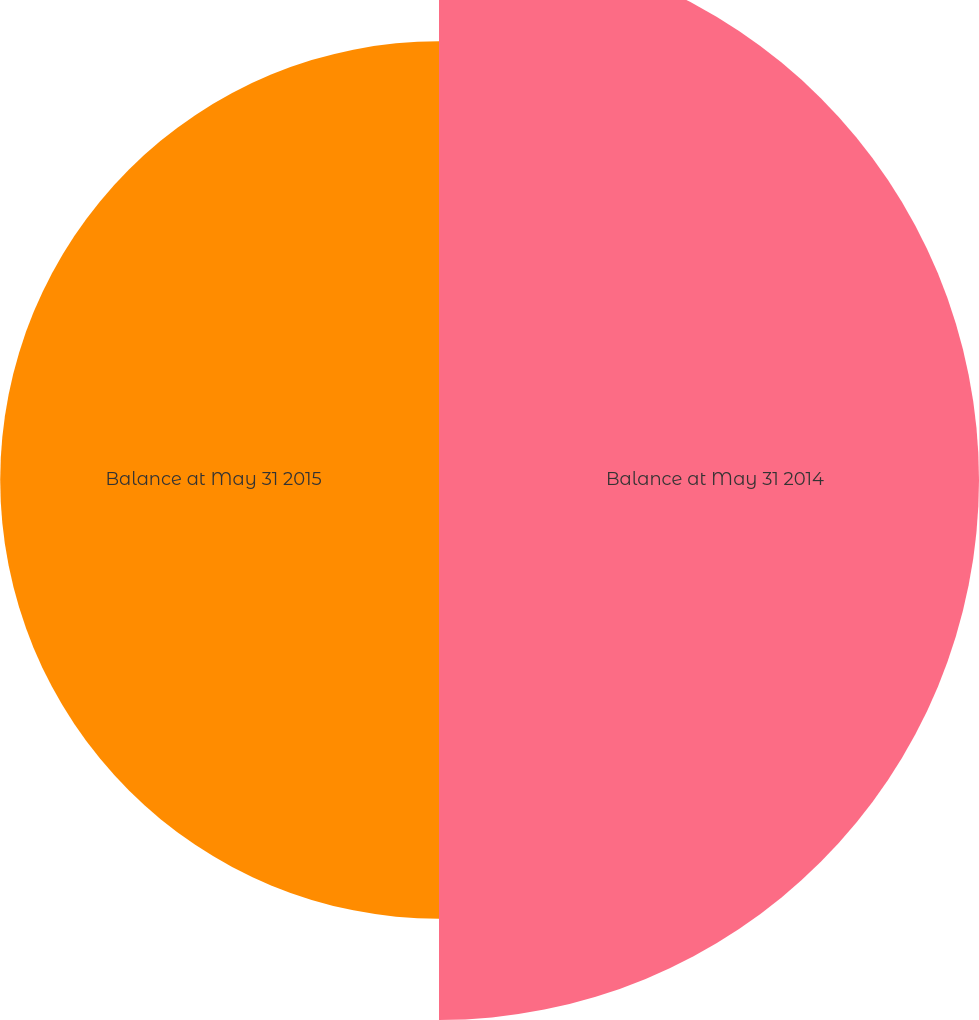Convert chart to OTSL. <chart><loc_0><loc_0><loc_500><loc_500><pie_chart><fcel>Balance at May 31 2014<fcel>Balance at May 31 2015<nl><fcel>55.17%<fcel>44.83%<nl></chart> 